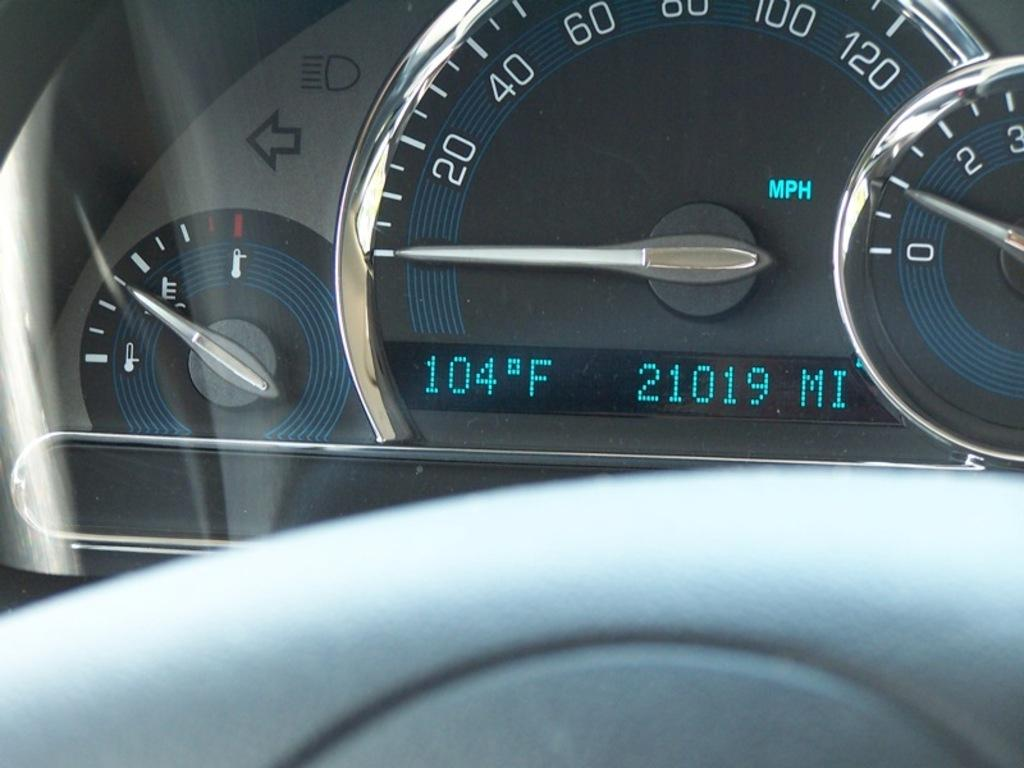What type of instrument is visible in the image? There is a speedometer in the image. Can you describe the object in front in the image? There is a white object in front in the image. What type of wilderness can be seen in the background of the image? There is no wilderness visible in the image; it only features a speedometer and a white object in front. What is the position of the speedometer in relation to the white object? The position of the speedometer in relation to the white object cannot be determined from the image alone, as there is no reference point provided. 